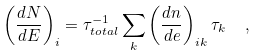Convert formula to latex. <formula><loc_0><loc_0><loc_500><loc_500>\left ( \frac { d N } { d E } \right ) _ { i } = \tau ^ { - 1 } _ { t o t a l } \sum _ { k } \left ( \frac { d n } { d e } \right ) _ { i k } \tau _ { k } \ \ ,</formula> 